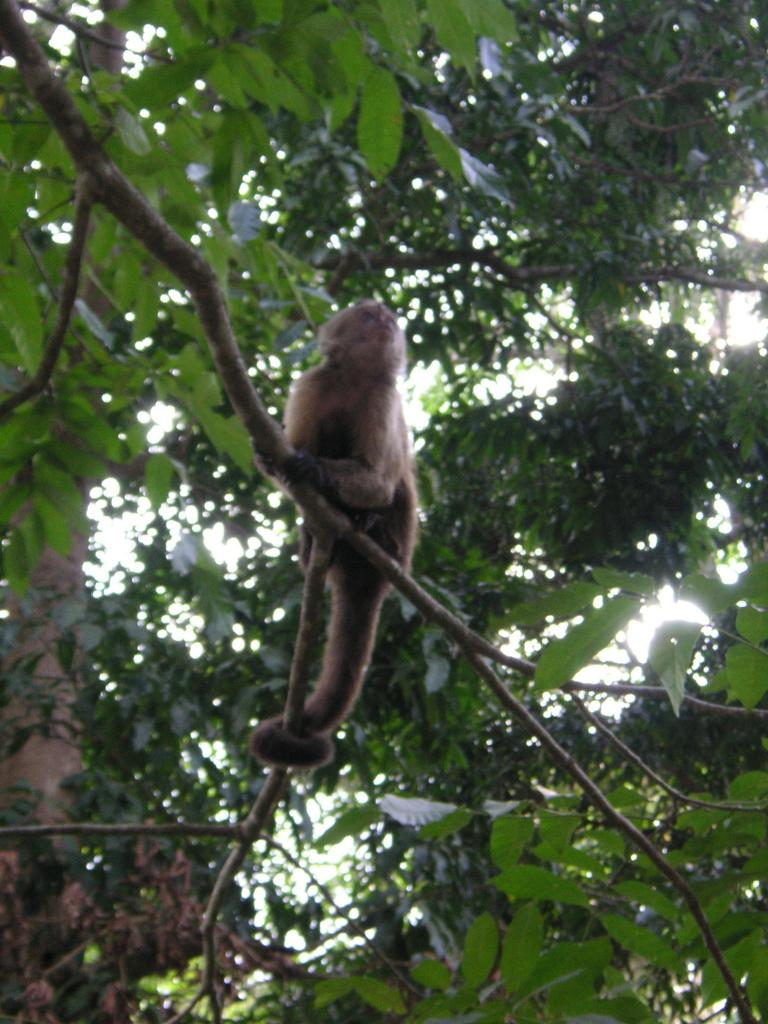What animal is located in the middle of the image? There is a monkey in the middle of the image. What type of vegetation can be seen in the image? There are trees visible in the image. What type of jeans is the man wearing in the image? There is no man present in the image, so it is not possible to determine what type of jeans he might be wearing. 